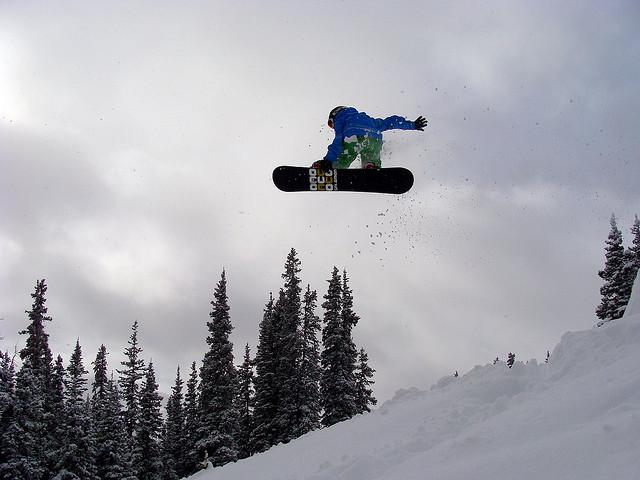What color is the snowboard?
Quick response, please. Black. Is he airborne?
Answer briefly. Yes. Is this a high jump?
Write a very short answer. Yes. Are the trees bare?
Write a very short answer. No. How high is the snowboarder?
Short answer required. 5 feet. What is the person doing?
Quick response, please. Snowboarding. Is the snowboard parallel to the mountain?
Write a very short answer. No. What sport are they doing?
Quick response, please. Snowboarding. Are there any clouds in the sky?
Keep it brief. Yes. Is it sunny?
Quick response, please. No. 